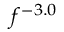<formula> <loc_0><loc_0><loc_500><loc_500>f ^ { - 3 . 0 }</formula> 